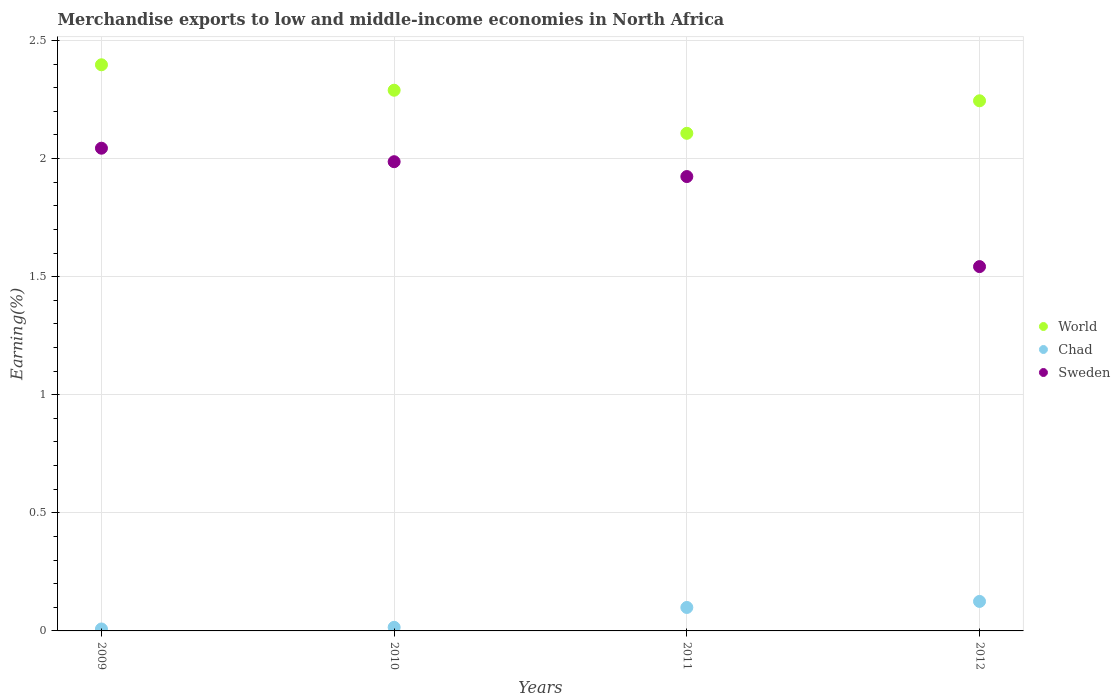How many different coloured dotlines are there?
Your answer should be compact. 3. Is the number of dotlines equal to the number of legend labels?
Your answer should be very brief. Yes. What is the percentage of amount earned from merchandise exports in Chad in 2012?
Make the answer very short. 0.12. Across all years, what is the maximum percentage of amount earned from merchandise exports in World?
Ensure brevity in your answer.  2.4. Across all years, what is the minimum percentage of amount earned from merchandise exports in Sweden?
Make the answer very short. 1.54. In which year was the percentage of amount earned from merchandise exports in Sweden maximum?
Your answer should be very brief. 2009. What is the total percentage of amount earned from merchandise exports in Chad in the graph?
Your answer should be compact. 0.25. What is the difference between the percentage of amount earned from merchandise exports in Sweden in 2011 and that in 2012?
Your answer should be compact. 0.38. What is the difference between the percentage of amount earned from merchandise exports in Sweden in 2012 and the percentage of amount earned from merchandise exports in World in 2009?
Your response must be concise. -0.85. What is the average percentage of amount earned from merchandise exports in Chad per year?
Make the answer very short. 0.06. In the year 2009, what is the difference between the percentage of amount earned from merchandise exports in World and percentage of amount earned from merchandise exports in Sweden?
Ensure brevity in your answer.  0.35. What is the ratio of the percentage of amount earned from merchandise exports in World in 2009 to that in 2012?
Your answer should be very brief. 1.07. Is the difference between the percentage of amount earned from merchandise exports in World in 2011 and 2012 greater than the difference between the percentage of amount earned from merchandise exports in Sweden in 2011 and 2012?
Your answer should be very brief. No. What is the difference between the highest and the second highest percentage of amount earned from merchandise exports in World?
Your answer should be compact. 0.11. What is the difference between the highest and the lowest percentage of amount earned from merchandise exports in Sweden?
Offer a very short reply. 0.5. Does the percentage of amount earned from merchandise exports in Sweden monotonically increase over the years?
Your answer should be very brief. No. Is the percentage of amount earned from merchandise exports in World strictly greater than the percentage of amount earned from merchandise exports in Chad over the years?
Keep it short and to the point. Yes. How many dotlines are there?
Offer a very short reply. 3. How many years are there in the graph?
Ensure brevity in your answer.  4. What is the difference between two consecutive major ticks on the Y-axis?
Keep it short and to the point. 0.5. Does the graph contain any zero values?
Offer a terse response. No. Does the graph contain grids?
Make the answer very short. Yes. How many legend labels are there?
Ensure brevity in your answer.  3. What is the title of the graph?
Ensure brevity in your answer.  Merchandise exports to low and middle-income economies in North Africa. Does "West Bank and Gaza" appear as one of the legend labels in the graph?
Offer a very short reply. No. What is the label or title of the Y-axis?
Keep it short and to the point. Earning(%). What is the Earning(%) in World in 2009?
Your answer should be very brief. 2.4. What is the Earning(%) in Chad in 2009?
Your answer should be compact. 0.01. What is the Earning(%) in Sweden in 2009?
Offer a terse response. 2.04. What is the Earning(%) in World in 2010?
Make the answer very short. 2.29. What is the Earning(%) of Chad in 2010?
Keep it short and to the point. 0.02. What is the Earning(%) in Sweden in 2010?
Offer a very short reply. 1.99. What is the Earning(%) in World in 2011?
Offer a terse response. 2.11. What is the Earning(%) of Chad in 2011?
Offer a terse response. 0.1. What is the Earning(%) in Sweden in 2011?
Keep it short and to the point. 1.92. What is the Earning(%) of World in 2012?
Your answer should be compact. 2.24. What is the Earning(%) in Chad in 2012?
Offer a very short reply. 0.12. What is the Earning(%) in Sweden in 2012?
Your answer should be very brief. 1.54. Across all years, what is the maximum Earning(%) in World?
Your answer should be compact. 2.4. Across all years, what is the maximum Earning(%) of Chad?
Offer a very short reply. 0.12. Across all years, what is the maximum Earning(%) of Sweden?
Your answer should be compact. 2.04. Across all years, what is the minimum Earning(%) in World?
Offer a terse response. 2.11. Across all years, what is the minimum Earning(%) of Chad?
Give a very brief answer. 0.01. Across all years, what is the minimum Earning(%) of Sweden?
Provide a short and direct response. 1.54. What is the total Earning(%) of World in the graph?
Provide a succinct answer. 9.04. What is the total Earning(%) in Chad in the graph?
Provide a short and direct response. 0.25. What is the total Earning(%) of Sweden in the graph?
Your answer should be very brief. 7.5. What is the difference between the Earning(%) in World in 2009 and that in 2010?
Ensure brevity in your answer.  0.11. What is the difference between the Earning(%) of Chad in 2009 and that in 2010?
Give a very brief answer. -0.01. What is the difference between the Earning(%) of Sweden in 2009 and that in 2010?
Keep it short and to the point. 0.06. What is the difference between the Earning(%) of World in 2009 and that in 2011?
Your answer should be very brief. 0.29. What is the difference between the Earning(%) of Chad in 2009 and that in 2011?
Provide a succinct answer. -0.09. What is the difference between the Earning(%) in Sweden in 2009 and that in 2011?
Keep it short and to the point. 0.12. What is the difference between the Earning(%) of World in 2009 and that in 2012?
Your answer should be compact. 0.15. What is the difference between the Earning(%) in Chad in 2009 and that in 2012?
Your answer should be very brief. -0.12. What is the difference between the Earning(%) of Sweden in 2009 and that in 2012?
Ensure brevity in your answer.  0.5. What is the difference between the Earning(%) of World in 2010 and that in 2011?
Offer a very short reply. 0.18. What is the difference between the Earning(%) in Chad in 2010 and that in 2011?
Make the answer very short. -0.08. What is the difference between the Earning(%) in Sweden in 2010 and that in 2011?
Make the answer very short. 0.06. What is the difference between the Earning(%) in World in 2010 and that in 2012?
Ensure brevity in your answer.  0.04. What is the difference between the Earning(%) in Chad in 2010 and that in 2012?
Give a very brief answer. -0.11. What is the difference between the Earning(%) of Sweden in 2010 and that in 2012?
Offer a terse response. 0.44. What is the difference between the Earning(%) of World in 2011 and that in 2012?
Ensure brevity in your answer.  -0.14. What is the difference between the Earning(%) in Chad in 2011 and that in 2012?
Your answer should be very brief. -0.03. What is the difference between the Earning(%) in Sweden in 2011 and that in 2012?
Your answer should be very brief. 0.38. What is the difference between the Earning(%) in World in 2009 and the Earning(%) in Chad in 2010?
Your answer should be very brief. 2.38. What is the difference between the Earning(%) in World in 2009 and the Earning(%) in Sweden in 2010?
Offer a terse response. 0.41. What is the difference between the Earning(%) of Chad in 2009 and the Earning(%) of Sweden in 2010?
Provide a succinct answer. -1.98. What is the difference between the Earning(%) in World in 2009 and the Earning(%) in Chad in 2011?
Make the answer very short. 2.3. What is the difference between the Earning(%) of World in 2009 and the Earning(%) of Sweden in 2011?
Keep it short and to the point. 0.47. What is the difference between the Earning(%) of Chad in 2009 and the Earning(%) of Sweden in 2011?
Your answer should be very brief. -1.92. What is the difference between the Earning(%) in World in 2009 and the Earning(%) in Chad in 2012?
Provide a succinct answer. 2.27. What is the difference between the Earning(%) in World in 2009 and the Earning(%) in Sweden in 2012?
Provide a short and direct response. 0.85. What is the difference between the Earning(%) of Chad in 2009 and the Earning(%) of Sweden in 2012?
Give a very brief answer. -1.53. What is the difference between the Earning(%) in World in 2010 and the Earning(%) in Chad in 2011?
Your answer should be compact. 2.19. What is the difference between the Earning(%) of World in 2010 and the Earning(%) of Sweden in 2011?
Give a very brief answer. 0.37. What is the difference between the Earning(%) in Chad in 2010 and the Earning(%) in Sweden in 2011?
Your answer should be compact. -1.91. What is the difference between the Earning(%) in World in 2010 and the Earning(%) in Chad in 2012?
Offer a very short reply. 2.16. What is the difference between the Earning(%) of World in 2010 and the Earning(%) of Sweden in 2012?
Offer a very short reply. 0.75. What is the difference between the Earning(%) in Chad in 2010 and the Earning(%) in Sweden in 2012?
Provide a succinct answer. -1.53. What is the difference between the Earning(%) in World in 2011 and the Earning(%) in Chad in 2012?
Your answer should be very brief. 1.98. What is the difference between the Earning(%) in World in 2011 and the Earning(%) in Sweden in 2012?
Give a very brief answer. 0.56. What is the difference between the Earning(%) of Chad in 2011 and the Earning(%) of Sweden in 2012?
Your answer should be very brief. -1.44. What is the average Earning(%) in World per year?
Your answer should be very brief. 2.26. What is the average Earning(%) in Chad per year?
Give a very brief answer. 0.06. What is the average Earning(%) in Sweden per year?
Your response must be concise. 1.87. In the year 2009, what is the difference between the Earning(%) in World and Earning(%) in Chad?
Keep it short and to the point. 2.39. In the year 2009, what is the difference between the Earning(%) in World and Earning(%) in Sweden?
Your response must be concise. 0.35. In the year 2009, what is the difference between the Earning(%) of Chad and Earning(%) of Sweden?
Your response must be concise. -2.04. In the year 2010, what is the difference between the Earning(%) in World and Earning(%) in Chad?
Keep it short and to the point. 2.27. In the year 2010, what is the difference between the Earning(%) of World and Earning(%) of Sweden?
Ensure brevity in your answer.  0.3. In the year 2010, what is the difference between the Earning(%) of Chad and Earning(%) of Sweden?
Provide a succinct answer. -1.97. In the year 2011, what is the difference between the Earning(%) in World and Earning(%) in Chad?
Offer a terse response. 2.01. In the year 2011, what is the difference between the Earning(%) of World and Earning(%) of Sweden?
Offer a terse response. 0.18. In the year 2011, what is the difference between the Earning(%) in Chad and Earning(%) in Sweden?
Ensure brevity in your answer.  -1.82. In the year 2012, what is the difference between the Earning(%) in World and Earning(%) in Chad?
Ensure brevity in your answer.  2.12. In the year 2012, what is the difference between the Earning(%) in World and Earning(%) in Sweden?
Your response must be concise. 0.7. In the year 2012, what is the difference between the Earning(%) of Chad and Earning(%) of Sweden?
Make the answer very short. -1.42. What is the ratio of the Earning(%) in World in 2009 to that in 2010?
Provide a short and direct response. 1.05. What is the ratio of the Earning(%) of Chad in 2009 to that in 2010?
Offer a terse response. 0.54. What is the ratio of the Earning(%) of Sweden in 2009 to that in 2010?
Make the answer very short. 1.03. What is the ratio of the Earning(%) of World in 2009 to that in 2011?
Your answer should be very brief. 1.14. What is the ratio of the Earning(%) in Chad in 2009 to that in 2011?
Provide a succinct answer. 0.08. What is the ratio of the Earning(%) of Sweden in 2009 to that in 2011?
Your answer should be compact. 1.06. What is the ratio of the Earning(%) of World in 2009 to that in 2012?
Make the answer very short. 1.07. What is the ratio of the Earning(%) of Chad in 2009 to that in 2012?
Give a very brief answer. 0.07. What is the ratio of the Earning(%) of Sweden in 2009 to that in 2012?
Ensure brevity in your answer.  1.32. What is the ratio of the Earning(%) of World in 2010 to that in 2011?
Ensure brevity in your answer.  1.09. What is the ratio of the Earning(%) in Chad in 2010 to that in 2011?
Your answer should be very brief. 0.15. What is the ratio of the Earning(%) in Sweden in 2010 to that in 2011?
Provide a short and direct response. 1.03. What is the ratio of the Earning(%) of World in 2010 to that in 2012?
Ensure brevity in your answer.  1.02. What is the ratio of the Earning(%) of Chad in 2010 to that in 2012?
Your answer should be compact. 0.12. What is the ratio of the Earning(%) in Sweden in 2010 to that in 2012?
Your answer should be compact. 1.29. What is the ratio of the Earning(%) in World in 2011 to that in 2012?
Keep it short and to the point. 0.94. What is the ratio of the Earning(%) of Chad in 2011 to that in 2012?
Provide a short and direct response. 0.8. What is the ratio of the Earning(%) of Sweden in 2011 to that in 2012?
Offer a terse response. 1.25. What is the difference between the highest and the second highest Earning(%) of World?
Give a very brief answer. 0.11. What is the difference between the highest and the second highest Earning(%) of Chad?
Provide a short and direct response. 0.03. What is the difference between the highest and the second highest Earning(%) of Sweden?
Ensure brevity in your answer.  0.06. What is the difference between the highest and the lowest Earning(%) in World?
Keep it short and to the point. 0.29. What is the difference between the highest and the lowest Earning(%) in Chad?
Give a very brief answer. 0.12. What is the difference between the highest and the lowest Earning(%) of Sweden?
Give a very brief answer. 0.5. 